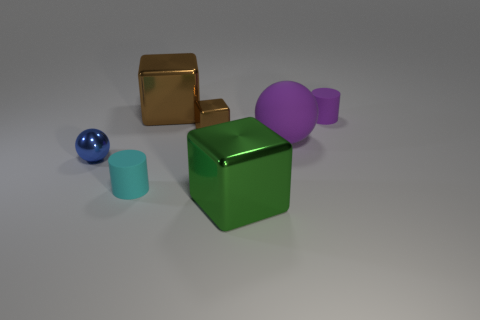There is a sphere that is left of the small brown cube; what is it made of?
Offer a terse response. Metal. What size is the cube in front of the purple matte object that is in front of the small purple rubber thing?
Your answer should be compact. Large. What number of gray cubes have the same size as the purple matte cylinder?
Offer a very short reply. 0. Do the large metal cube to the left of the small metal block and the small metallic thing that is to the right of the tiny cyan rubber cylinder have the same color?
Provide a succinct answer. Yes. There is a green cube; are there any shiny things behind it?
Make the answer very short. Yes. What is the color of the large thing that is on the right side of the small brown metal block and behind the small ball?
Provide a succinct answer. Purple. Are there any tiny things of the same color as the big rubber ball?
Your answer should be compact. Yes. Do the big object that is in front of the metallic ball and the large object behind the small brown thing have the same material?
Provide a succinct answer. Yes. What is the size of the object that is in front of the cyan rubber object?
Offer a very short reply. Large. What is the size of the cyan cylinder?
Provide a short and direct response. Small. 